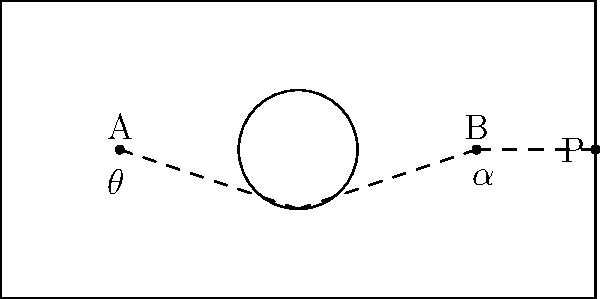In a billiards game, you need to pocket ball B using ball A. There's a circular obstacle in the center of the table. Given that the angle of reflection equals the angle of incidence, what should be the angle $\theta$ at which you hit ball A to ensure ball B goes into pocket P? To solve this problem, we'll use the principle that the angle of incidence equals the angle of reflection. Let's break it down step by step:

1) First, we need to identify the key points:
   - Ball A is at (20,25)
   - The obstacle's edge is at (50,15)
   - Ball B is at (80,25)
   - The pocket P is at (100,25)

2) We can see that for ball B to go into pocket P, it needs to travel in a straight line from (80,25) to (100,25).

3) For this to happen, ball A needs to hit the obstacle at point (50,15) so that it reflects towards ball B.

4) Let's call the angle between the line AB and the horizontal $\alpha$.

5) We can calculate $\alpha$ using the arctangent function:
   $\alpha = \arctan(\frac{25-15}{80-50}) = \arctan(\frac{10}{30}) \approx 18.43°$

6) Due to the law of reflection, the angle of incidence (which is $\theta$) must equal the angle of reflection ($\alpha$).

7) Therefore, $\theta = \alpha \approx 18.43°$

8) To double-check, we can calculate $\theta$ directly:
   $\theta = \arctan(\frac{25-15}{50-20}) = \arctan(\frac{10}{30}) \approx 18.43°$

This confirms our result.
Answer: $\theta \approx 18.43°$ 